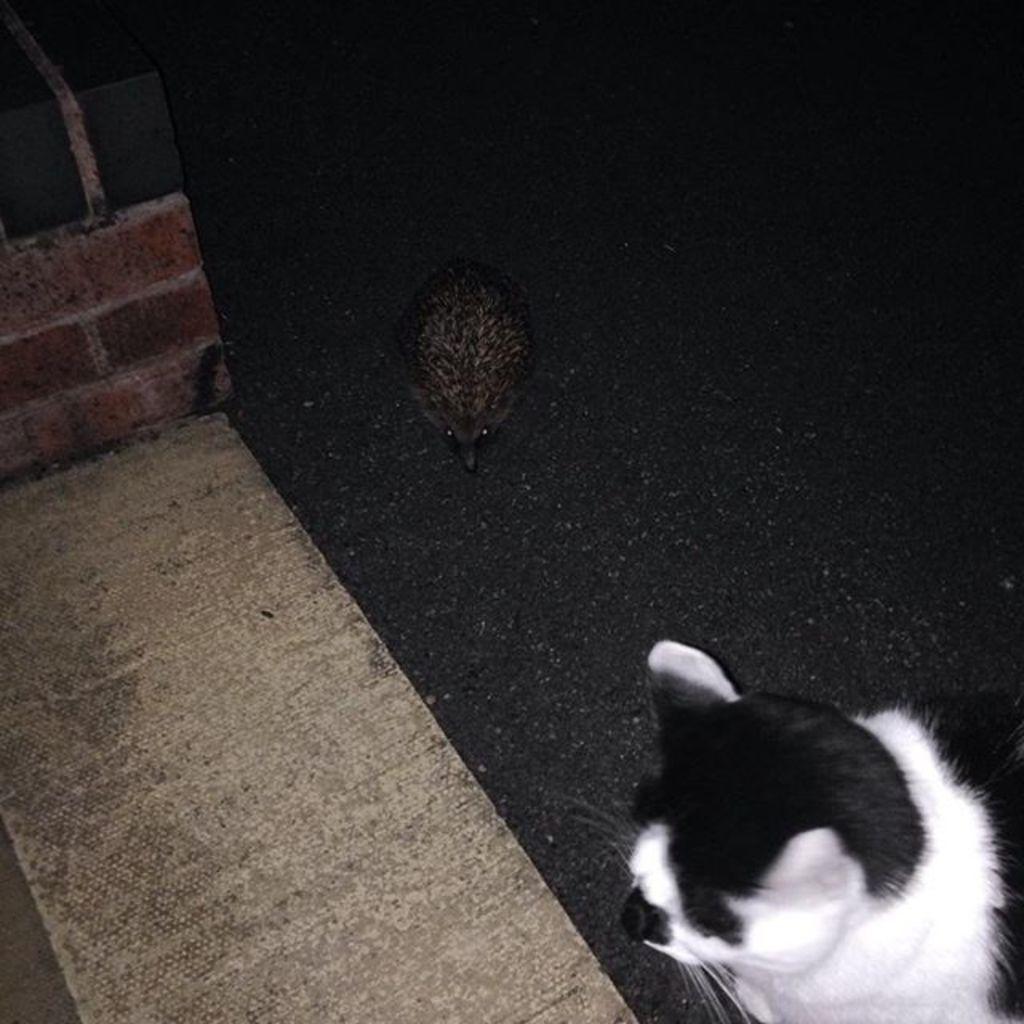Can you describe this image briefly? This image is taken during night time. In this image we can see the bird and also the cat on the path. On the left we can see the pillar with bricks. We can also see the surface. 